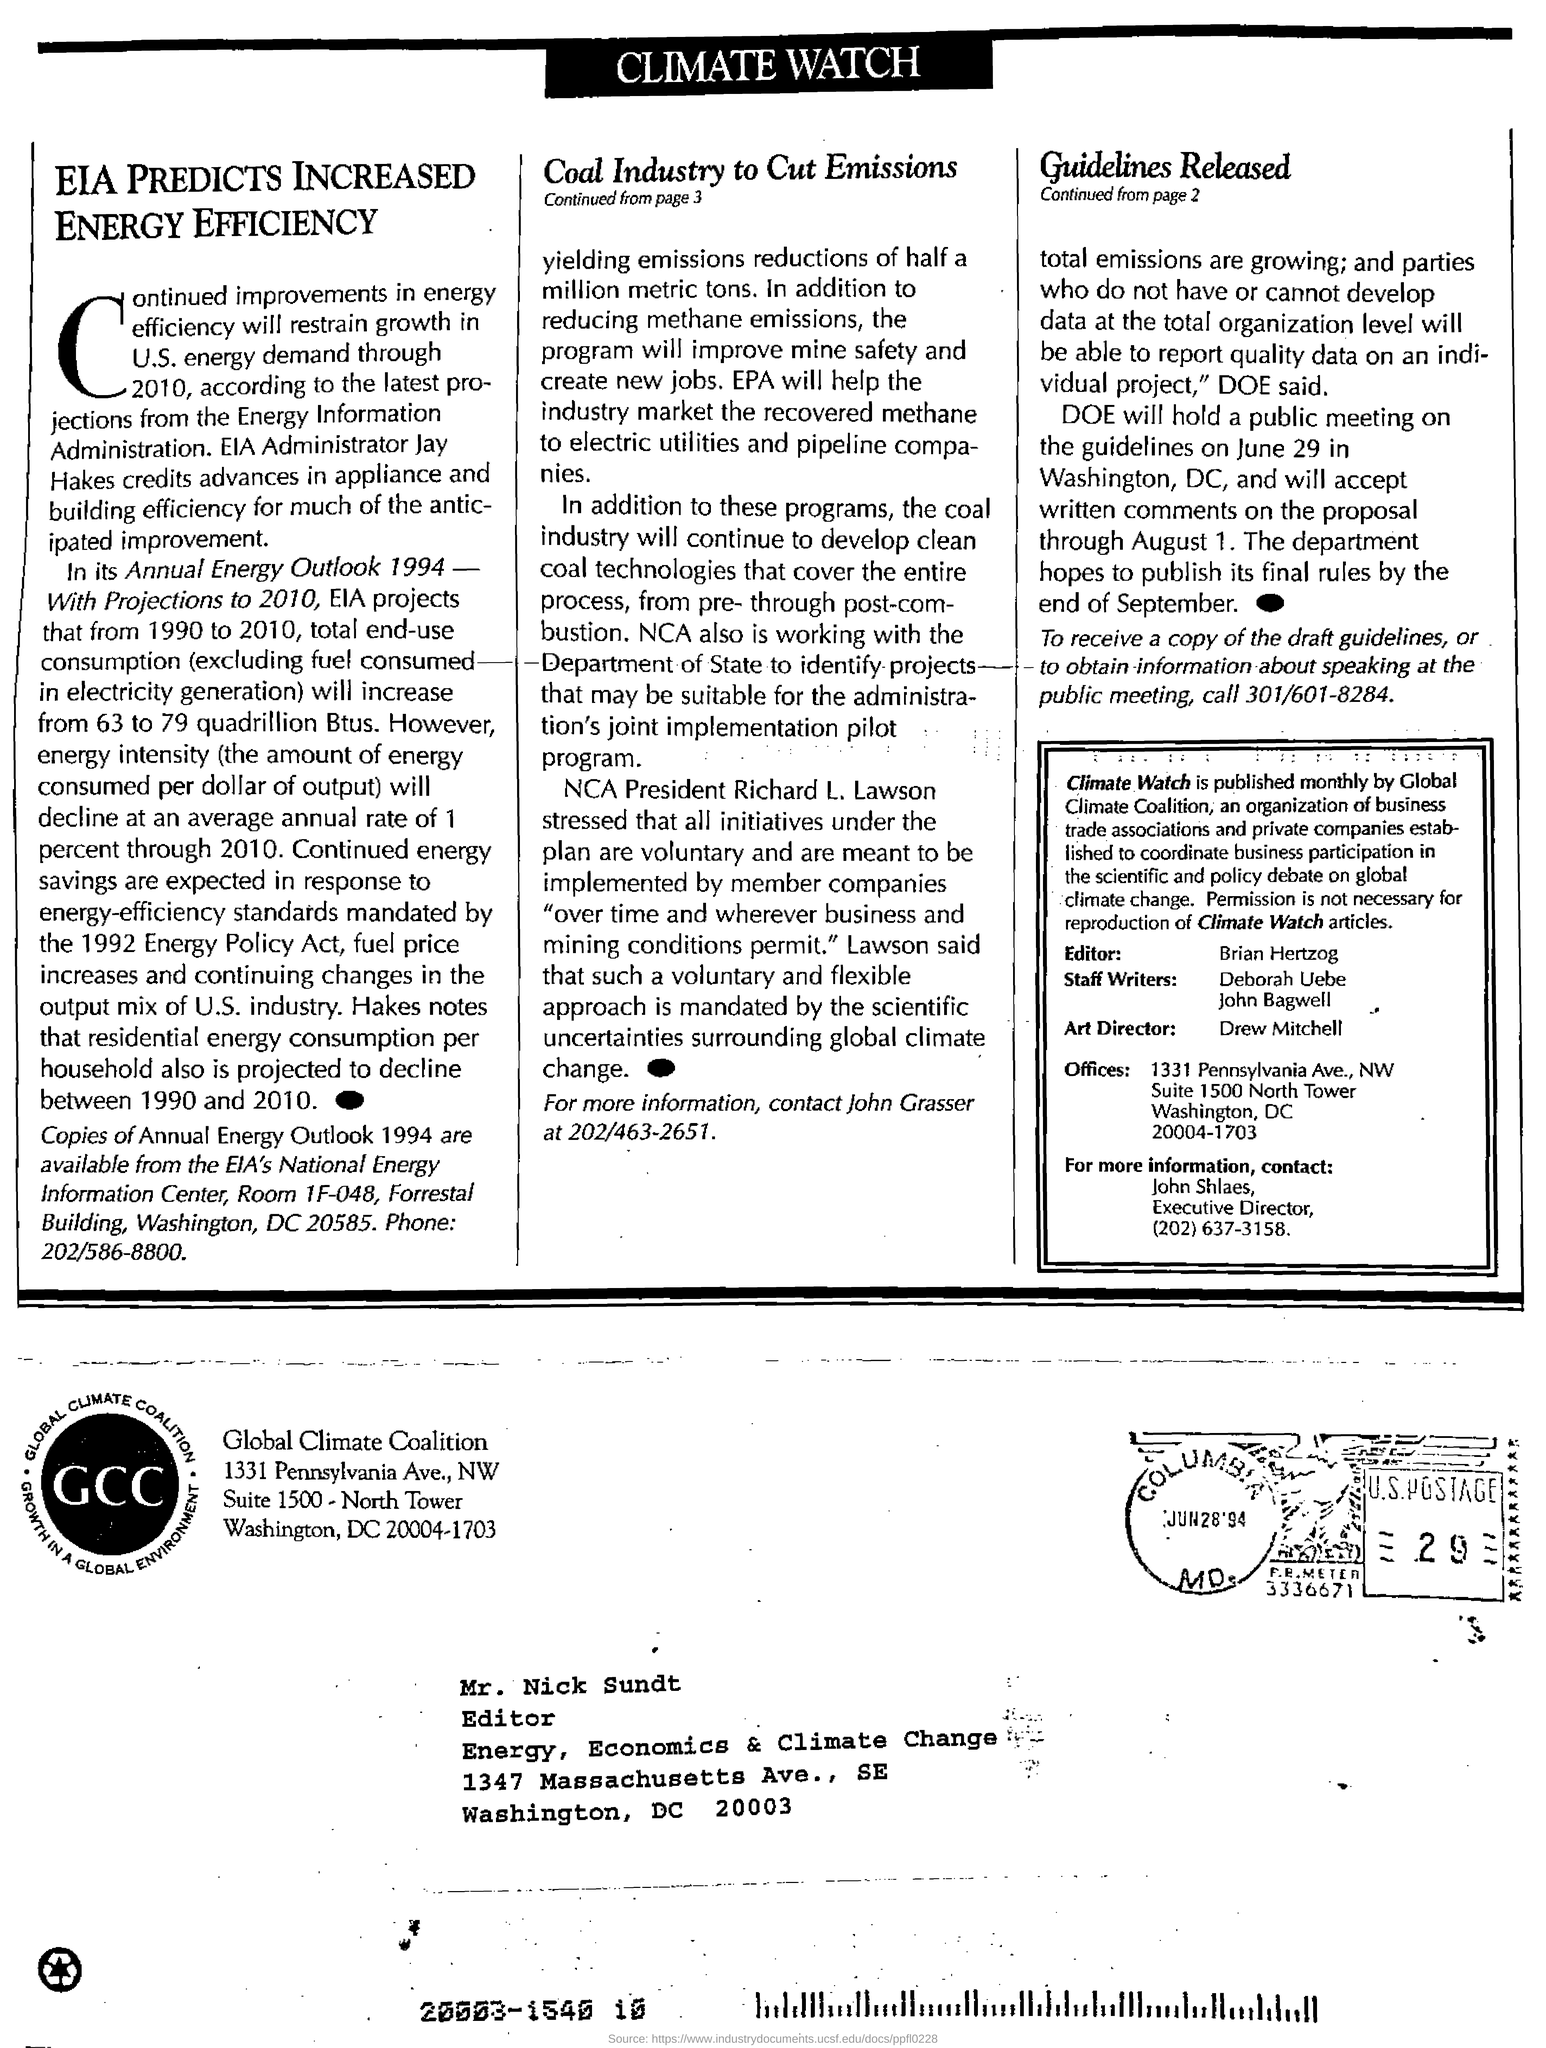Indicate a few pertinent items in this graphic. The National Cotton Association's president is Richard L. Lawson. The individual who currently holds the position of President of the National Cooperative Bank of Africa is Richard L. Lawson. The letter is addressed to Mr. Nick Sundt. It is known that Drew Mitchell is the art director. Brian Hertzog is the editor of Climate Watch. 